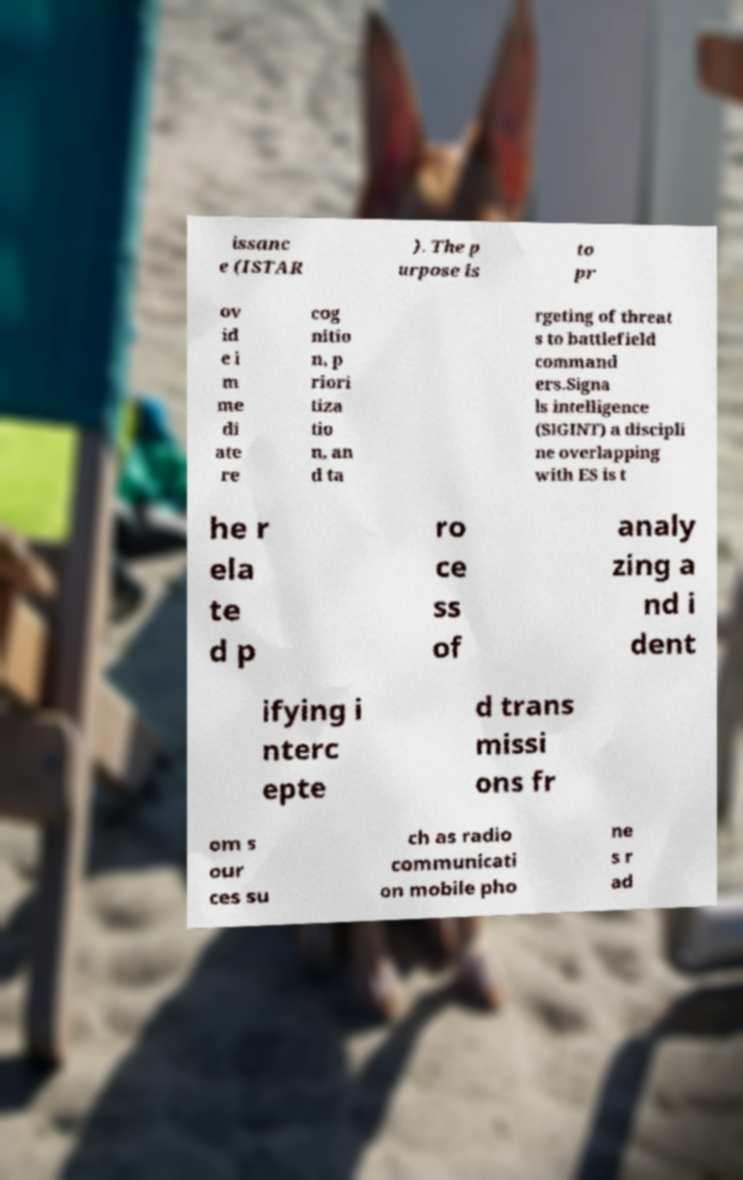Please read and relay the text visible in this image. What does it say? issanc e (ISTAR ). The p urpose is to pr ov id e i m me di ate re cog nitio n, p riori tiza tio n, an d ta rgeting of threat s to battlefield command ers.Signa ls intelligence (SIGINT) a discipli ne overlapping with ES is t he r ela te d p ro ce ss of analy zing a nd i dent ifying i nterc epte d trans missi ons fr om s our ces su ch as radio communicati on mobile pho ne s r ad 